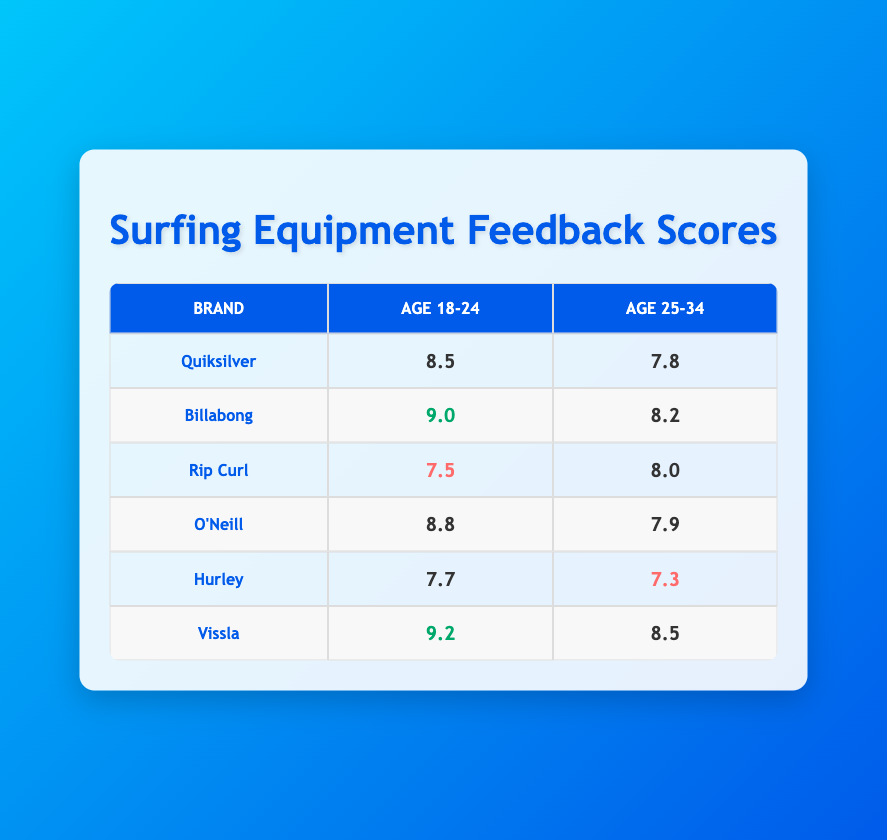What is the highest feedback score for the age group 18-24? Looking at the table under the "Age 18-24" column, the highest score is 9.2, which corresponds to the brand Vissla.
Answer: 9.2 What is the feedback score for Quiksilver in the age group 25-34? From the table, Quiksilver has a feedback score of 7.8 in the age group 25-34, as seen in the corresponding row.
Answer: 7.8 Is the feedback score for Rip Curl in the age group 18-24 above 8? By checking Rip Curl's score for the age group 18-24, we see it is 7.5, which is not above 8.
Answer: No What is the average feedback score for the brand Billabong across both age groups? To find the average, add the scores for Billabong: 9.0 (age 18-24) + 8.2 (age 25-34) = 17.2. Then divide by 2: 17.2 / 2 = 8.6.
Answer: 8.6 Which brand received the lowest feedback score among ages 25-34? In the age group 25-34, the brand Hurley has the lowest feedback score of 7.3, identified by comparing all scores in that row.
Answer: 7.3 Is the feedback score for O'Neill in the age group 18-24 higher than that of Hurley in the same age group? O'Neill has a score of 8.8 and Hurley has a score of 7.7 in the age group 18-24. Comparing these, O'Neill is indeed higher.
Answer: Yes What brand has a feedback score of 8.0 for the age group 25-34? By checking the table under the age group 25-34, the brand Rip Curl has a feedback score of 8.0, found in that row.
Answer: Rip Curl If we looked only at the age group 18-24, how many brands scored above 8.0? In the age group 18-24, we check the scores: Billabong (9.0), O'Neill (8.8), and Vissla (9.2) are the ones above 8.0. Thus, there are three brands.
Answer: 3 What is the difference between the highest and lowest scores for the age group 25-34? The highest score in this age group is 8.5 (Vissla) and the lowest is 7.3 (Hurley). The difference is calculated as 8.5 - 7.3 = 1.2.
Answer: 1.2 